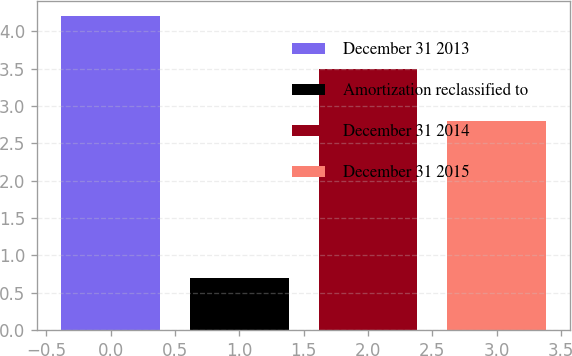Convert chart. <chart><loc_0><loc_0><loc_500><loc_500><bar_chart><fcel>December 31 2013<fcel>Amortization reclassified to<fcel>December 31 2014<fcel>December 31 2015<nl><fcel>4.2<fcel>0.7<fcel>3.5<fcel>2.8<nl></chart> 